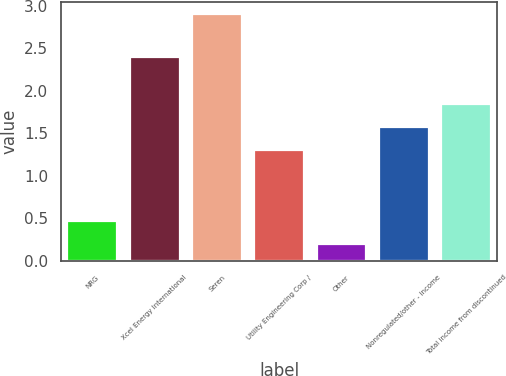<chart> <loc_0><loc_0><loc_500><loc_500><bar_chart><fcel>NRG<fcel>Xcel Energy International<fcel>Seren<fcel>Utility Engineering Corp /<fcel>Other<fcel>Nonregulated/other - income<fcel>Total income from discontinued<nl><fcel>0.47<fcel>2.4<fcel>2.9<fcel>1.3<fcel>0.2<fcel>1.57<fcel>1.84<nl></chart> 